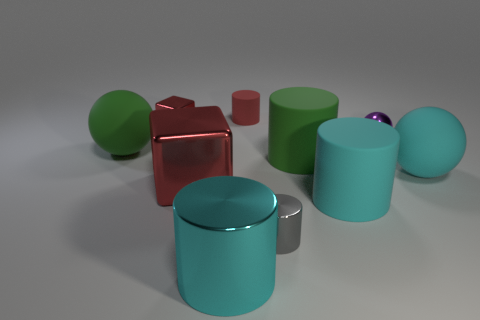Subtract all blue cylinders. Subtract all cyan blocks. How many cylinders are left? 5 Subtract all spheres. How many objects are left? 7 Subtract all gray metal cylinders. Subtract all red rubber objects. How many objects are left? 8 Add 8 red shiny things. How many red shiny things are left? 10 Add 2 small cyan shiny blocks. How many small cyan shiny blocks exist? 2 Subtract 0 red spheres. How many objects are left? 10 